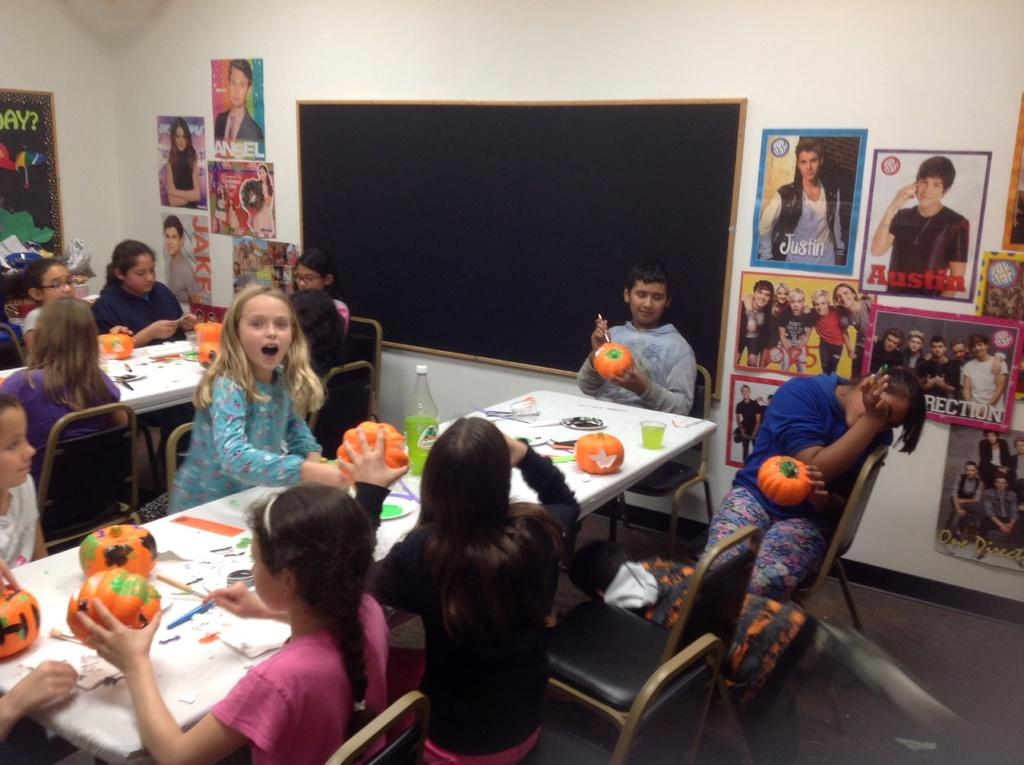How many kids are present in the image? There are several kids in the image. What are the kids doing in the image? The kids are painting a pumpkin. What other decorations or items can be seen in the image? There are many posters in the image. What is attached to the wall in the image? There is a blackboard attached to the wall in the image. What type of downtown scene can be seen in the image? There is no downtown scene present in the image; it features kids painting a pumpkin and other items. 